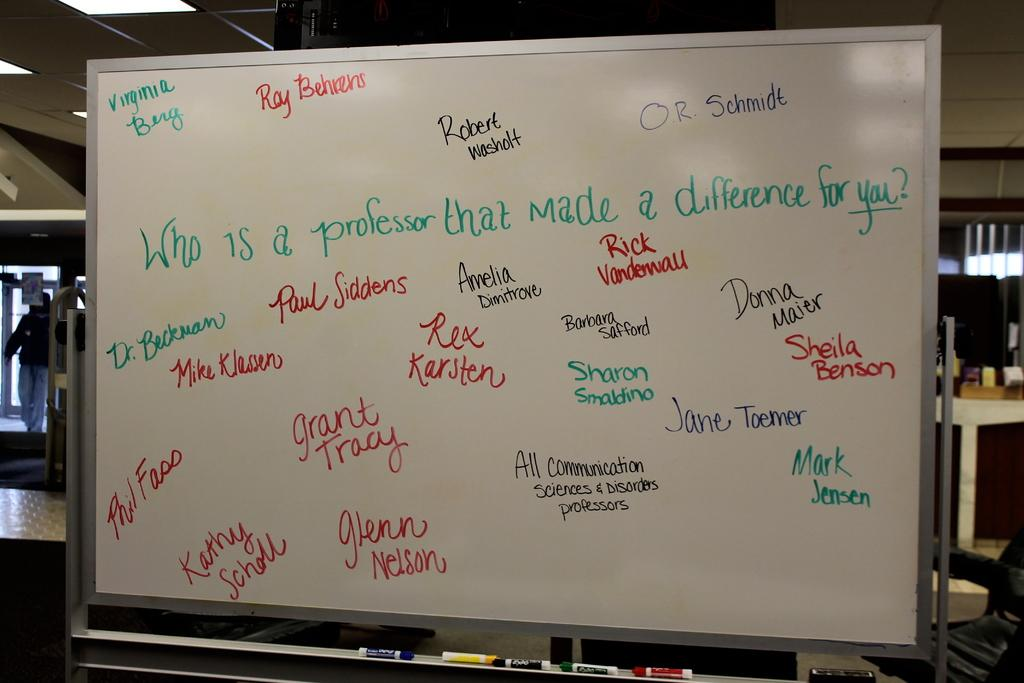<image>
Write a terse but informative summary of the picture. A dry erase board that has mutiple names on it. 